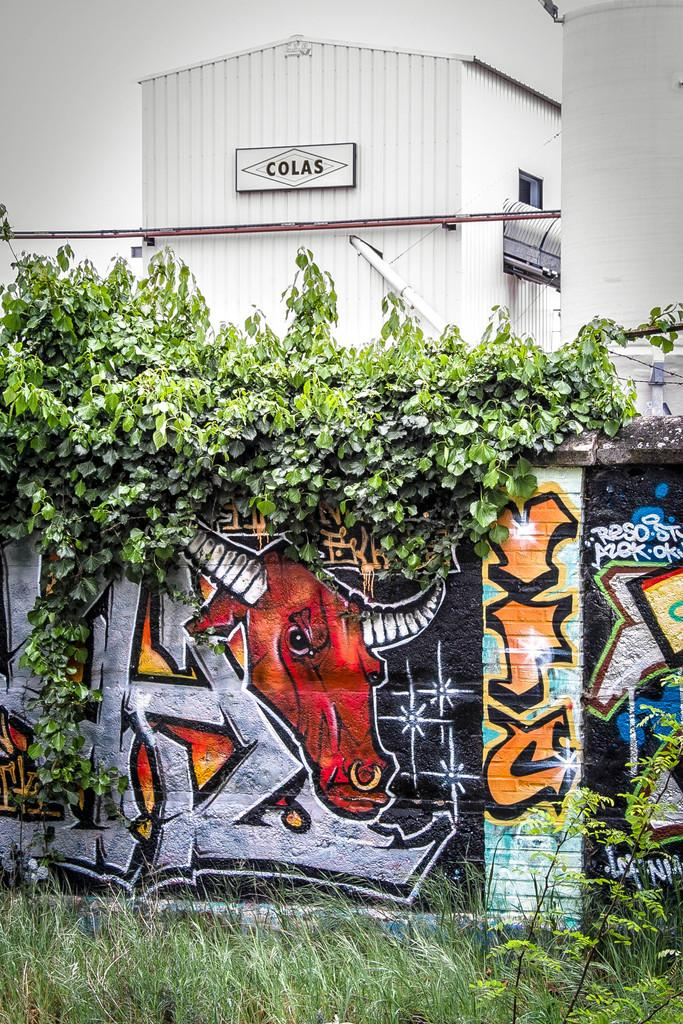What type of vegetation is present in the image? There is grass in the image. What can be found on the wall in the image? There is a painting on the wall in the image. What else can be seen in the background of the image? There are plants and a shed in the background of the image. What type of pleasure does the committee derive from the home in the image? There is no mention of a committee or a home in the image, so it is not possible to answer this question. 